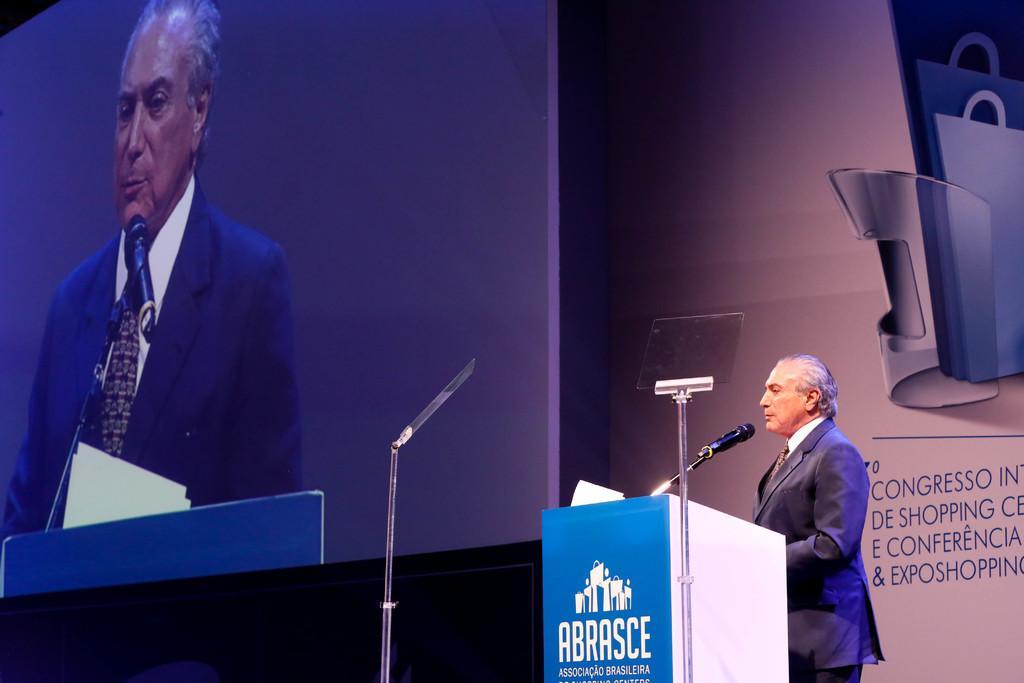In one or two sentences, can you explain what this image depicts? In this picture I can see there is a person standing here and there is a wooden table here and there is a microphone attached to the wooden table. In the backdrop there is a wall and there is a screen. 